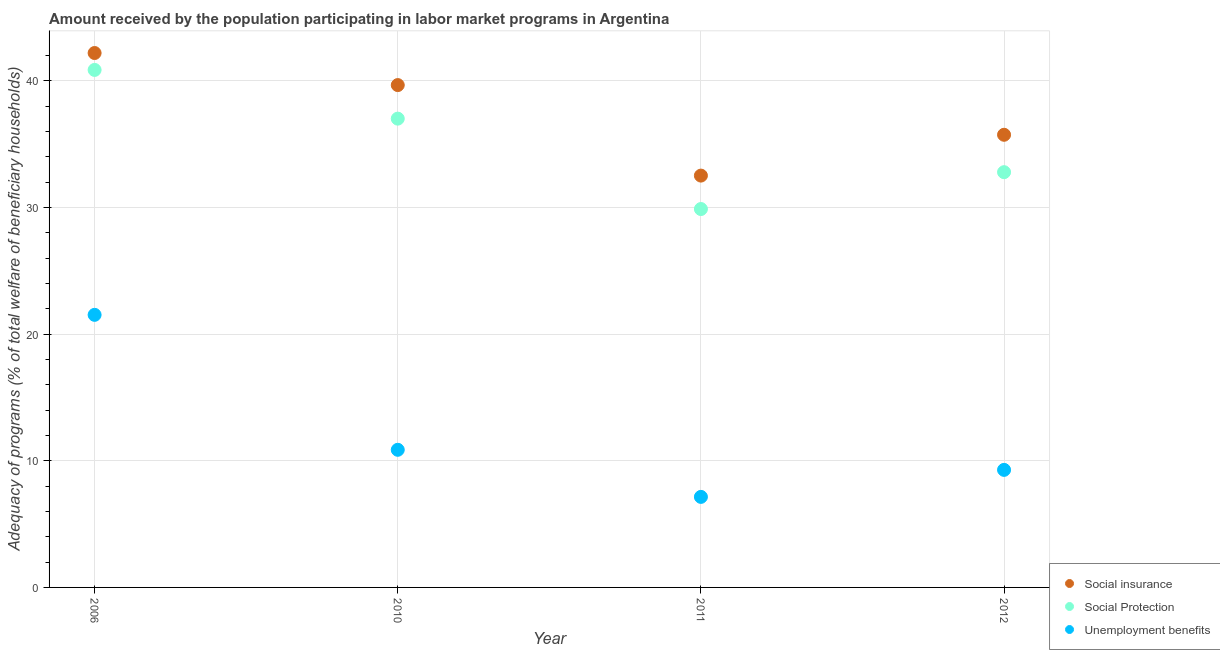What is the amount received by the population participating in social insurance programs in 2012?
Your response must be concise. 35.74. Across all years, what is the maximum amount received by the population participating in unemployment benefits programs?
Your response must be concise. 21.52. Across all years, what is the minimum amount received by the population participating in unemployment benefits programs?
Give a very brief answer. 7.15. In which year was the amount received by the population participating in social protection programs maximum?
Your answer should be very brief. 2006. In which year was the amount received by the population participating in unemployment benefits programs minimum?
Provide a succinct answer. 2011. What is the total amount received by the population participating in unemployment benefits programs in the graph?
Provide a short and direct response. 48.82. What is the difference between the amount received by the population participating in social protection programs in 2010 and that in 2011?
Ensure brevity in your answer.  7.14. What is the difference between the amount received by the population participating in unemployment benefits programs in 2011 and the amount received by the population participating in social insurance programs in 2012?
Provide a succinct answer. -28.59. What is the average amount received by the population participating in social insurance programs per year?
Give a very brief answer. 37.53. In the year 2012, what is the difference between the amount received by the population participating in social protection programs and amount received by the population participating in social insurance programs?
Ensure brevity in your answer.  -2.95. In how many years, is the amount received by the population participating in social insurance programs greater than 38 %?
Ensure brevity in your answer.  2. What is the ratio of the amount received by the population participating in social insurance programs in 2006 to that in 2010?
Your response must be concise. 1.06. Is the amount received by the population participating in social insurance programs in 2006 less than that in 2010?
Your response must be concise. No. Is the difference between the amount received by the population participating in social insurance programs in 2006 and 2012 greater than the difference between the amount received by the population participating in social protection programs in 2006 and 2012?
Provide a short and direct response. No. What is the difference between the highest and the second highest amount received by the population participating in unemployment benefits programs?
Your response must be concise. 10.65. What is the difference between the highest and the lowest amount received by the population participating in unemployment benefits programs?
Provide a short and direct response. 14.37. In how many years, is the amount received by the population participating in social insurance programs greater than the average amount received by the population participating in social insurance programs taken over all years?
Make the answer very short. 2. Does the amount received by the population participating in unemployment benefits programs monotonically increase over the years?
Give a very brief answer. No. Is the amount received by the population participating in social insurance programs strictly greater than the amount received by the population participating in unemployment benefits programs over the years?
Your response must be concise. Yes. How many years are there in the graph?
Your response must be concise. 4. Are the values on the major ticks of Y-axis written in scientific E-notation?
Ensure brevity in your answer.  No. Does the graph contain grids?
Your answer should be compact. Yes. What is the title of the graph?
Give a very brief answer. Amount received by the population participating in labor market programs in Argentina. What is the label or title of the X-axis?
Give a very brief answer. Year. What is the label or title of the Y-axis?
Offer a terse response. Adequacy of programs (% of total welfare of beneficiary households). What is the Adequacy of programs (% of total welfare of beneficiary households) of Social insurance in 2006?
Offer a terse response. 42.2. What is the Adequacy of programs (% of total welfare of beneficiary households) of Social Protection in 2006?
Make the answer very short. 40.86. What is the Adequacy of programs (% of total welfare of beneficiary households) of Unemployment benefits in 2006?
Your answer should be very brief. 21.52. What is the Adequacy of programs (% of total welfare of beneficiary households) of Social insurance in 2010?
Provide a short and direct response. 39.66. What is the Adequacy of programs (% of total welfare of beneficiary households) of Social Protection in 2010?
Give a very brief answer. 37.01. What is the Adequacy of programs (% of total welfare of beneficiary households) in Unemployment benefits in 2010?
Make the answer very short. 10.87. What is the Adequacy of programs (% of total welfare of beneficiary households) in Social insurance in 2011?
Offer a very short reply. 32.52. What is the Adequacy of programs (% of total welfare of beneficiary households) in Social Protection in 2011?
Ensure brevity in your answer.  29.88. What is the Adequacy of programs (% of total welfare of beneficiary households) in Unemployment benefits in 2011?
Your answer should be very brief. 7.15. What is the Adequacy of programs (% of total welfare of beneficiary households) in Social insurance in 2012?
Keep it short and to the point. 35.74. What is the Adequacy of programs (% of total welfare of beneficiary households) in Social Protection in 2012?
Offer a very short reply. 32.79. What is the Adequacy of programs (% of total welfare of beneficiary households) in Unemployment benefits in 2012?
Provide a short and direct response. 9.28. Across all years, what is the maximum Adequacy of programs (% of total welfare of beneficiary households) in Social insurance?
Offer a very short reply. 42.2. Across all years, what is the maximum Adequacy of programs (% of total welfare of beneficiary households) in Social Protection?
Make the answer very short. 40.86. Across all years, what is the maximum Adequacy of programs (% of total welfare of beneficiary households) of Unemployment benefits?
Offer a terse response. 21.52. Across all years, what is the minimum Adequacy of programs (% of total welfare of beneficiary households) in Social insurance?
Your answer should be compact. 32.52. Across all years, what is the minimum Adequacy of programs (% of total welfare of beneficiary households) of Social Protection?
Your response must be concise. 29.88. Across all years, what is the minimum Adequacy of programs (% of total welfare of beneficiary households) of Unemployment benefits?
Keep it short and to the point. 7.15. What is the total Adequacy of programs (% of total welfare of beneficiary households) in Social insurance in the graph?
Give a very brief answer. 150.11. What is the total Adequacy of programs (% of total welfare of beneficiary households) of Social Protection in the graph?
Provide a short and direct response. 140.54. What is the total Adequacy of programs (% of total welfare of beneficiary households) in Unemployment benefits in the graph?
Give a very brief answer. 48.82. What is the difference between the Adequacy of programs (% of total welfare of beneficiary households) of Social insurance in 2006 and that in 2010?
Offer a terse response. 2.53. What is the difference between the Adequacy of programs (% of total welfare of beneficiary households) in Social Protection in 2006 and that in 2010?
Provide a short and direct response. 3.85. What is the difference between the Adequacy of programs (% of total welfare of beneficiary households) in Unemployment benefits in 2006 and that in 2010?
Your response must be concise. 10.65. What is the difference between the Adequacy of programs (% of total welfare of beneficiary households) in Social insurance in 2006 and that in 2011?
Offer a very short reply. 9.68. What is the difference between the Adequacy of programs (% of total welfare of beneficiary households) in Social Protection in 2006 and that in 2011?
Keep it short and to the point. 10.98. What is the difference between the Adequacy of programs (% of total welfare of beneficiary households) of Unemployment benefits in 2006 and that in 2011?
Your response must be concise. 14.37. What is the difference between the Adequacy of programs (% of total welfare of beneficiary households) of Social insurance in 2006 and that in 2012?
Provide a succinct answer. 6.46. What is the difference between the Adequacy of programs (% of total welfare of beneficiary households) in Social Protection in 2006 and that in 2012?
Your answer should be compact. 8.07. What is the difference between the Adequacy of programs (% of total welfare of beneficiary households) of Unemployment benefits in 2006 and that in 2012?
Your response must be concise. 12.24. What is the difference between the Adequacy of programs (% of total welfare of beneficiary households) of Social insurance in 2010 and that in 2011?
Offer a terse response. 7.15. What is the difference between the Adequacy of programs (% of total welfare of beneficiary households) in Social Protection in 2010 and that in 2011?
Provide a short and direct response. 7.14. What is the difference between the Adequacy of programs (% of total welfare of beneficiary households) in Unemployment benefits in 2010 and that in 2011?
Your answer should be very brief. 3.72. What is the difference between the Adequacy of programs (% of total welfare of beneficiary households) of Social insurance in 2010 and that in 2012?
Offer a terse response. 3.92. What is the difference between the Adequacy of programs (% of total welfare of beneficiary households) of Social Protection in 2010 and that in 2012?
Your answer should be very brief. 4.23. What is the difference between the Adequacy of programs (% of total welfare of beneficiary households) of Unemployment benefits in 2010 and that in 2012?
Make the answer very short. 1.59. What is the difference between the Adequacy of programs (% of total welfare of beneficiary households) in Social insurance in 2011 and that in 2012?
Your response must be concise. -3.22. What is the difference between the Adequacy of programs (% of total welfare of beneficiary households) of Social Protection in 2011 and that in 2012?
Ensure brevity in your answer.  -2.91. What is the difference between the Adequacy of programs (% of total welfare of beneficiary households) in Unemployment benefits in 2011 and that in 2012?
Ensure brevity in your answer.  -2.13. What is the difference between the Adequacy of programs (% of total welfare of beneficiary households) of Social insurance in 2006 and the Adequacy of programs (% of total welfare of beneficiary households) of Social Protection in 2010?
Provide a succinct answer. 5.18. What is the difference between the Adequacy of programs (% of total welfare of beneficiary households) of Social insurance in 2006 and the Adequacy of programs (% of total welfare of beneficiary households) of Unemployment benefits in 2010?
Make the answer very short. 31.33. What is the difference between the Adequacy of programs (% of total welfare of beneficiary households) of Social Protection in 2006 and the Adequacy of programs (% of total welfare of beneficiary households) of Unemployment benefits in 2010?
Keep it short and to the point. 29.99. What is the difference between the Adequacy of programs (% of total welfare of beneficiary households) in Social insurance in 2006 and the Adequacy of programs (% of total welfare of beneficiary households) in Social Protection in 2011?
Provide a short and direct response. 12.32. What is the difference between the Adequacy of programs (% of total welfare of beneficiary households) of Social insurance in 2006 and the Adequacy of programs (% of total welfare of beneficiary households) of Unemployment benefits in 2011?
Your response must be concise. 35.05. What is the difference between the Adequacy of programs (% of total welfare of beneficiary households) in Social Protection in 2006 and the Adequacy of programs (% of total welfare of beneficiary households) in Unemployment benefits in 2011?
Offer a very short reply. 33.71. What is the difference between the Adequacy of programs (% of total welfare of beneficiary households) of Social insurance in 2006 and the Adequacy of programs (% of total welfare of beneficiary households) of Social Protection in 2012?
Your answer should be very brief. 9.41. What is the difference between the Adequacy of programs (% of total welfare of beneficiary households) of Social insurance in 2006 and the Adequacy of programs (% of total welfare of beneficiary households) of Unemployment benefits in 2012?
Give a very brief answer. 32.91. What is the difference between the Adequacy of programs (% of total welfare of beneficiary households) in Social Protection in 2006 and the Adequacy of programs (% of total welfare of beneficiary households) in Unemployment benefits in 2012?
Your answer should be compact. 31.58. What is the difference between the Adequacy of programs (% of total welfare of beneficiary households) in Social insurance in 2010 and the Adequacy of programs (% of total welfare of beneficiary households) in Social Protection in 2011?
Give a very brief answer. 9.79. What is the difference between the Adequacy of programs (% of total welfare of beneficiary households) of Social insurance in 2010 and the Adequacy of programs (% of total welfare of beneficiary households) of Unemployment benefits in 2011?
Provide a succinct answer. 32.51. What is the difference between the Adequacy of programs (% of total welfare of beneficiary households) of Social Protection in 2010 and the Adequacy of programs (% of total welfare of beneficiary households) of Unemployment benefits in 2011?
Ensure brevity in your answer.  29.87. What is the difference between the Adequacy of programs (% of total welfare of beneficiary households) of Social insurance in 2010 and the Adequacy of programs (% of total welfare of beneficiary households) of Social Protection in 2012?
Keep it short and to the point. 6.88. What is the difference between the Adequacy of programs (% of total welfare of beneficiary households) of Social insurance in 2010 and the Adequacy of programs (% of total welfare of beneficiary households) of Unemployment benefits in 2012?
Offer a very short reply. 30.38. What is the difference between the Adequacy of programs (% of total welfare of beneficiary households) in Social Protection in 2010 and the Adequacy of programs (% of total welfare of beneficiary households) in Unemployment benefits in 2012?
Keep it short and to the point. 27.73. What is the difference between the Adequacy of programs (% of total welfare of beneficiary households) in Social insurance in 2011 and the Adequacy of programs (% of total welfare of beneficiary households) in Social Protection in 2012?
Ensure brevity in your answer.  -0.27. What is the difference between the Adequacy of programs (% of total welfare of beneficiary households) in Social insurance in 2011 and the Adequacy of programs (% of total welfare of beneficiary households) in Unemployment benefits in 2012?
Your answer should be compact. 23.23. What is the difference between the Adequacy of programs (% of total welfare of beneficiary households) in Social Protection in 2011 and the Adequacy of programs (% of total welfare of beneficiary households) in Unemployment benefits in 2012?
Your response must be concise. 20.6. What is the average Adequacy of programs (% of total welfare of beneficiary households) of Social insurance per year?
Keep it short and to the point. 37.53. What is the average Adequacy of programs (% of total welfare of beneficiary households) in Social Protection per year?
Your response must be concise. 35.13. What is the average Adequacy of programs (% of total welfare of beneficiary households) of Unemployment benefits per year?
Offer a very short reply. 12.2. In the year 2006, what is the difference between the Adequacy of programs (% of total welfare of beneficiary households) in Social insurance and Adequacy of programs (% of total welfare of beneficiary households) in Social Protection?
Give a very brief answer. 1.33. In the year 2006, what is the difference between the Adequacy of programs (% of total welfare of beneficiary households) of Social insurance and Adequacy of programs (% of total welfare of beneficiary households) of Unemployment benefits?
Offer a terse response. 20.67. In the year 2006, what is the difference between the Adequacy of programs (% of total welfare of beneficiary households) in Social Protection and Adequacy of programs (% of total welfare of beneficiary households) in Unemployment benefits?
Keep it short and to the point. 19.34. In the year 2010, what is the difference between the Adequacy of programs (% of total welfare of beneficiary households) of Social insurance and Adequacy of programs (% of total welfare of beneficiary households) of Social Protection?
Your response must be concise. 2.65. In the year 2010, what is the difference between the Adequacy of programs (% of total welfare of beneficiary households) in Social insurance and Adequacy of programs (% of total welfare of beneficiary households) in Unemployment benefits?
Offer a very short reply. 28.8. In the year 2010, what is the difference between the Adequacy of programs (% of total welfare of beneficiary households) of Social Protection and Adequacy of programs (% of total welfare of beneficiary households) of Unemployment benefits?
Keep it short and to the point. 26.15. In the year 2011, what is the difference between the Adequacy of programs (% of total welfare of beneficiary households) of Social insurance and Adequacy of programs (% of total welfare of beneficiary households) of Social Protection?
Keep it short and to the point. 2.64. In the year 2011, what is the difference between the Adequacy of programs (% of total welfare of beneficiary households) of Social insurance and Adequacy of programs (% of total welfare of beneficiary households) of Unemployment benefits?
Your answer should be very brief. 25.37. In the year 2011, what is the difference between the Adequacy of programs (% of total welfare of beneficiary households) of Social Protection and Adequacy of programs (% of total welfare of beneficiary households) of Unemployment benefits?
Keep it short and to the point. 22.73. In the year 2012, what is the difference between the Adequacy of programs (% of total welfare of beneficiary households) of Social insurance and Adequacy of programs (% of total welfare of beneficiary households) of Social Protection?
Your response must be concise. 2.95. In the year 2012, what is the difference between the Adequacy of programs (% of total welfare of beneficiary households) in Social insurance and Adequacy of programs (% of total welfare of beneficiary households) in Unemployment benefits?
Your answer should be very brief. 26.46. In the year 2012, what is the difference between the Adequacy of programs (% of total welfare of beneficiary households) of Social Protection and Adequacy of programs (% of total welfare of beneficiary households) of Unemployment benefits?
Give a very brief answer. 23.5. What is the ratio of the Adequacy of programs (% of total welfare of beneficiary households) in Social insurance in 2006 to that in 2010?
Offer a very short reply. 1.06. What is the ratio of the Adequacy of programs (% of total welfare of beneficiary households) in Social Protection in 2006 to that in 2010?
Keep it short and to the point. 1.1. What is the ratio of the Adequacy of programs (% of total welfare of beneficiary households) of Unemployment benefits in 2006 to that in 2010?
Offer a terse response. 1.98. What is the ratio of the Adequacy of programs (% of total welfare of beneficiary households) of Social insurance in 2006 to that in 2011?
Provide a succinct answer. 1.3. What is the ratio of the Adequacy of programs (% of total welfare of beneficiary households) in Social Protection in 2006 to that in 2011?
Give a very brief answer. 1.37. What is the ratio of the Adequacy of programs (% of total welfare of beneficiary households) in Unemployment benefits in 2006 to that in 2011?
Offer a terse response. 3.01. What is the ratio of the Adequacy of programs (% of total welfare of beneficiary households) in Social insurance in 2006 to that in 2012?
Provide a short and direct response. 1.18. What is the ratio of the Adequacy of programs (% of total welfare of beneficiary households) of Social Protection in 2006 to that in 2012?
Give a very brief answer. 1.25. What is the ratio of the Adequacy of programs (% of total welfare of beneficiary households) of Unemployment benefits in 2006 to that in 2012?
Ensure brevity in your answer.  2.32. What is the ratio of the Adequacy of programs (% of total welfare of beneficiary households) of Social insurance in 2010 to that in 2011?
Your answer should be compact. 1.22. What is the ratio of the Adequacy of programs (% of total welfare of beneficiary households) of Social Protection in 2010 to that in 2011?
Offer a terse response. 1.24. What is the ratio of the Adequacy of programs (% of total welfare of beneficiary households) in Unemployment benefits in 2010 to that in 2011?
Provide a succinct answer. 1.52. What is the ratio of the Adequacy of programs (% of total welfare of beneficiary households) of Social insurance in 2010 to that in 2012?
Your answer should be compact. 1.11. What is the ratio of the Adequacy of programs (% of total welfare of beneficiary households) in Social Protection in 2010 to that in 2012?
Your answer should be compact. 1.13. What is the ratio of the Adequacy of programs (% of total welfare of beneficiary households) in Unemployment benefits in 2010 to that in 2012?
Provide a succinct answer. 1.17. What is the ratio of the Adequacy of programs (% of total welfare of beneficiary households) in Social insurance in 2011 to that in 2012?
Ensure brevity in your answer.  0.91. What is the ratio of the Adequacy of programs (% of total welfare of beneficiary households) in Social Protection in 2011 to that in 2012?
Offer a very short reply. 0.91. What is the ratio of the Adequacy of programs (% of total welfare of beneficiary households) in Unemployment benefits in 2011 to that in 2012?
Provide a succinct answer. 0.77. What is the difference between the highest and the second highest Adequacy of programs (% of total welfare of beneficiary households) in Social insurance?
Provide a succinct answer. 2.53. What is the difference between the highest and the second highest Adequacy of programs (% of total welfare of beneficiary households) in Social Protection?
Provide a short and direct response. 3.85. What is the difference between the highest and the second highest Adequacy of programs (% of total welfare of beneficiary households) in Unemployment benefits?
Your answer should be compact. 10.65. What is the difference between the highest and the lowest Adequacy of programs (% of total welfare of beneficiary households) in Social insurance?
Provide a short and direct response. 9.68. What is the difference between the highest and the lowest Adequacy of programs (% of total welfare of beneficiary households) in Social Protection?
Your answer should be compact. 10.98. What is the difference between the highest and the lowest Adequacy of programs (% of total welfare of beneficiary households) of Unemployment benefits?
Your answer should be compact. 14.37. 